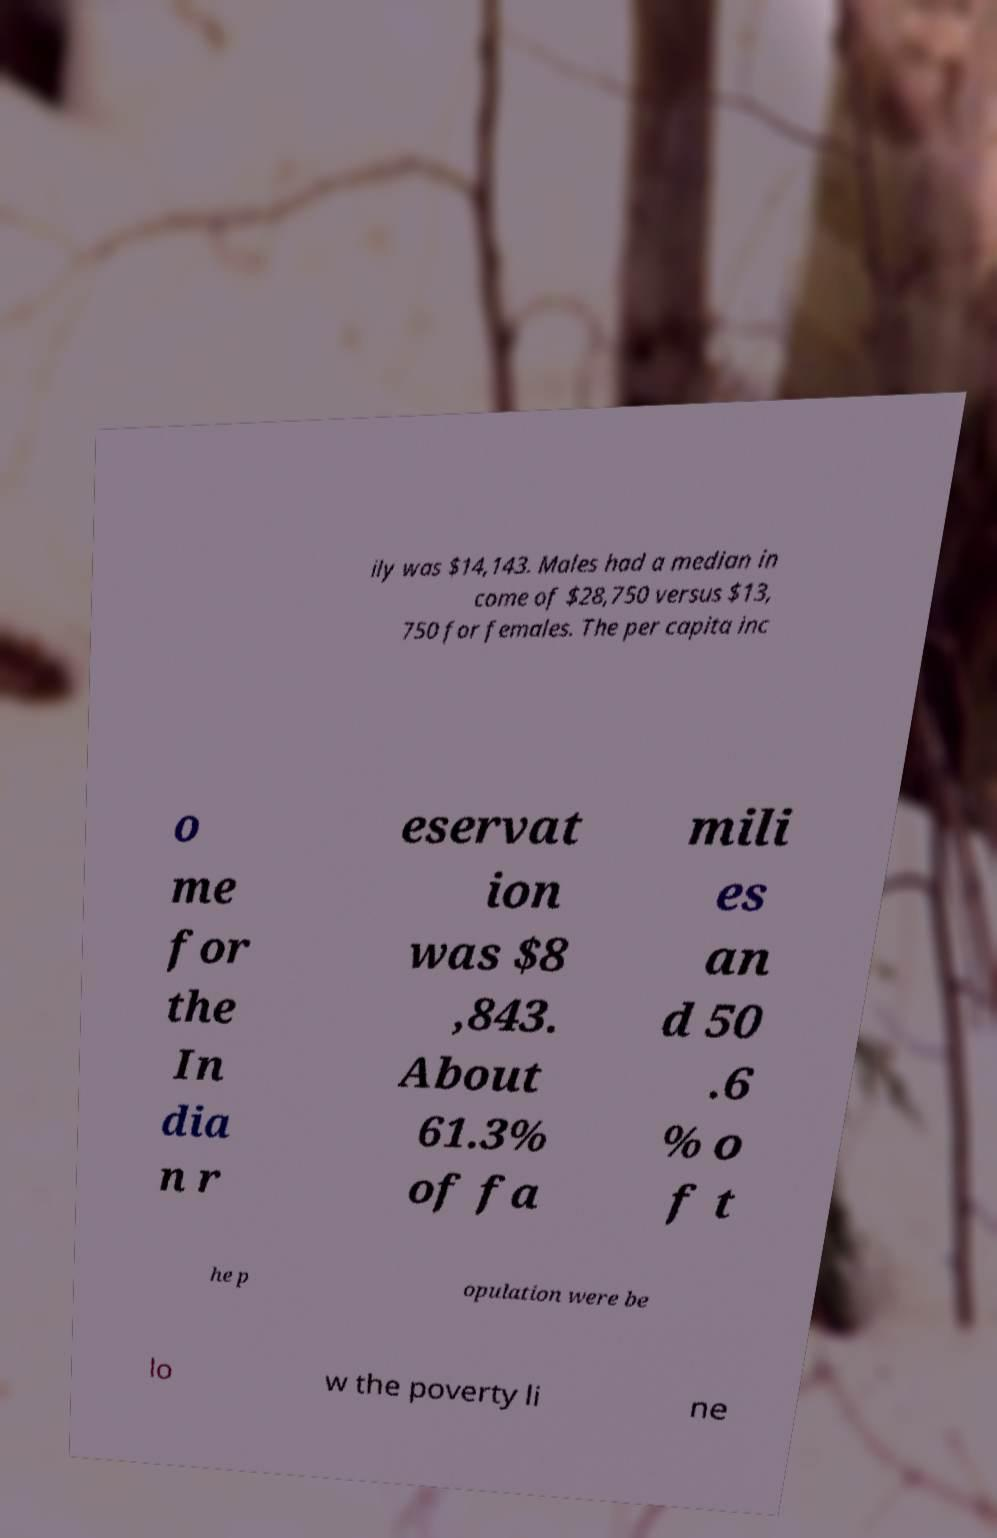Please read and relay the text visible in this image. What does it say? ily was $14,143. Males had a median in come of $28,750 versus $13, 750 for females. The per capita inc o me for the In dia n r eservat ion was $8 ,843. About 61.3% of fa mili es an d 50 .6 % o f t he p opulation were be lo w the poverty li ne 